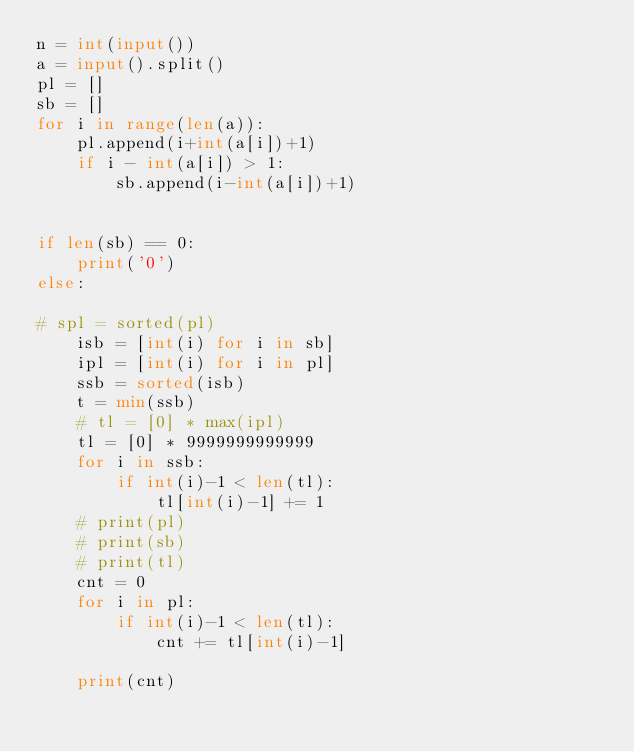<code> <loc_0><loc_0><loc_500><loc_500><_Python_>n = int(input())
a = input().split()
pl = []
sb = []
for i in range(len(a)):
	pl.append(i+int(a[i])+1)
	if i - int(a[i]) > 1:
		sb.append(i-int(a[i])+1)


if len(sb) == 0:
	print('0')
else:

# spl = sorted(pl)
	isb = [int(i) for i in sb]
	ipl = [int(i) for i in pl]
	ssb = sorted(isb)
	t = min(ssb)
	# tl = [0] * max(ipl)
	tl = [0] * 9999999999999
	for i in ssb:
		if int(i)-1 < len(tl):
			tl[int(i)-1] += 1
	# print(pl)
	# print(sb)
	# print(tl)
	cnt = 0
	for i in pl:
		if int(i)-1 < len(tl):
			cnt += tl[int(i)-1]

	print(cnt)
	

</code> 